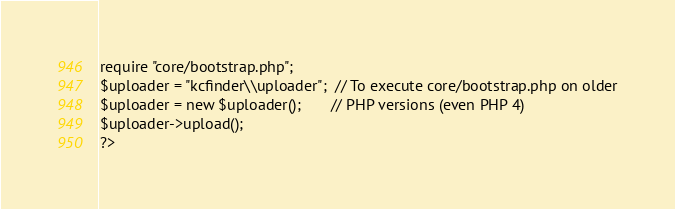<code> <loc_0><loc_0><loc_500><loc_500><_PHP_>
require "core/bootstrap.php";
$uploader = "kcfinder\\uploader";  // To execute core/bootstrap.php on older
$uploader = new $uploader();       // PHP versions (even PHP 4)
$uploader->upload();
?></code> 